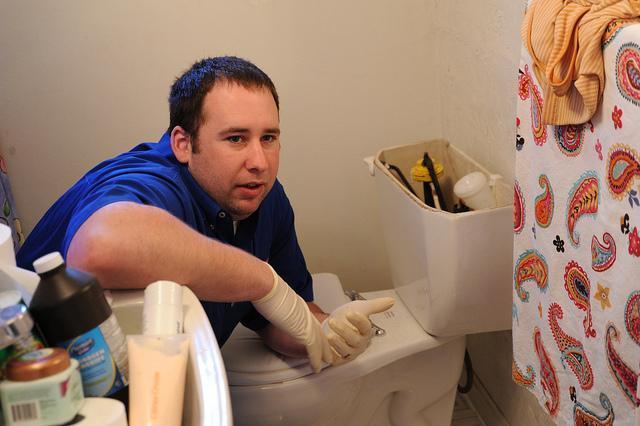How many umbrellas are there?
Give a very brief answer. 0. 